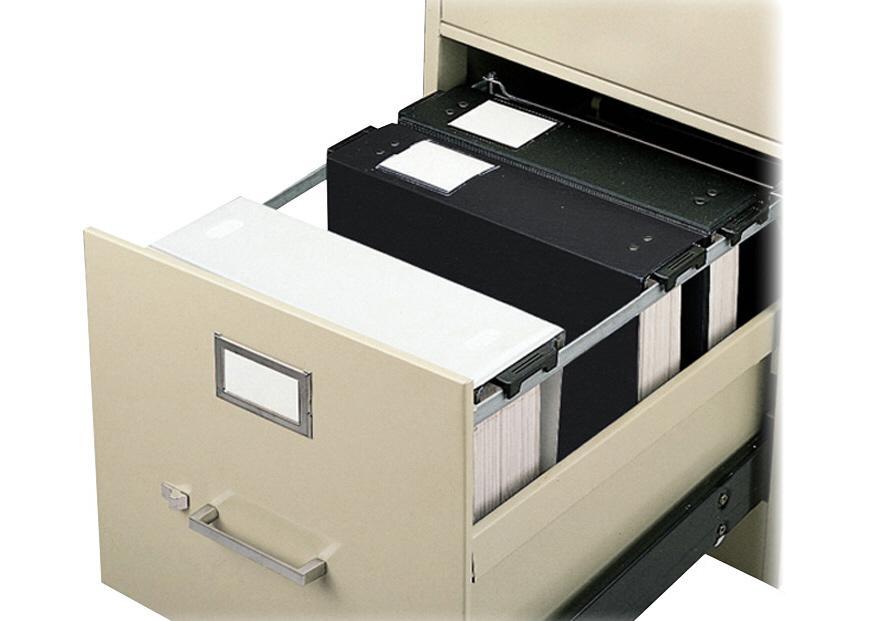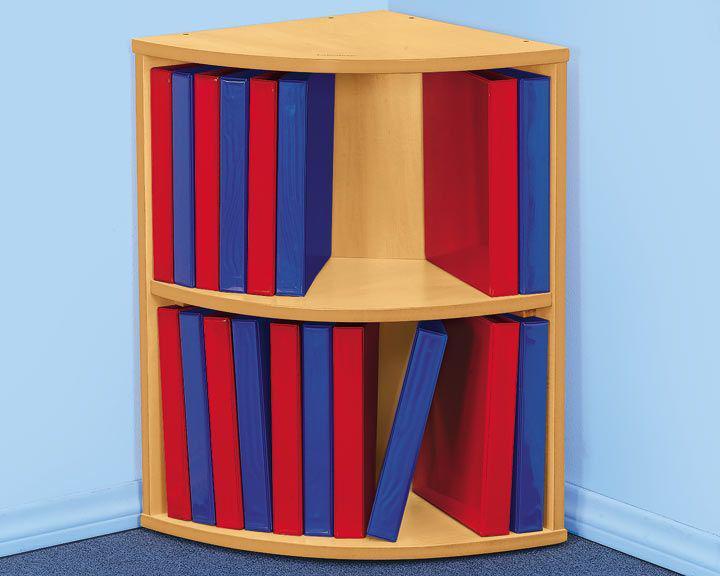The first image is the image on the left, the second image is the image on the right. Analyze the images presented: Is the assertion "One image shows overlapping binders of different solid colors arranged in a single curved, arching line." valid? Answer yes or no. No. 